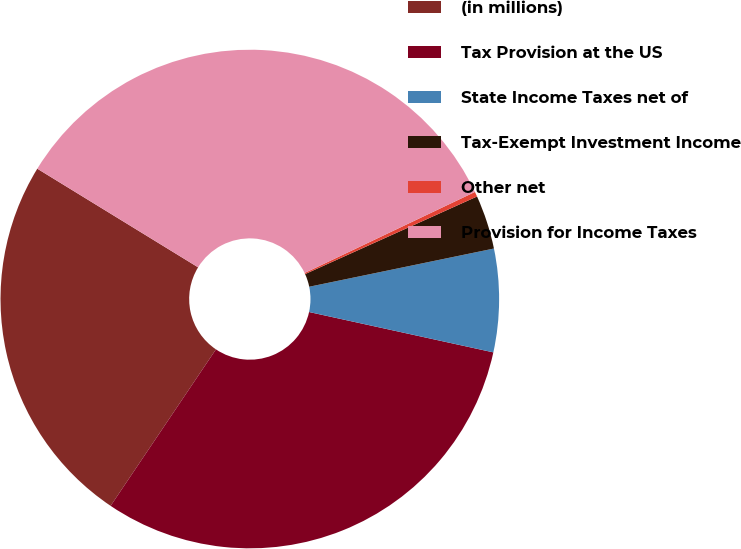<chart> <loc_0><loc_0><loc_500><loc_500><pie_chart><fcel>(in millions)<fcel>Tax Provision at the US<fcel>State Income Taxes net of<fcel>Tax-Exempt Investment Income<fcel>Other net<fcel>Provision for Income Taxes<nl><fcel>24.33%<fcel>31.0%<fcel>6.68%<fcel>3.5%<fcel>0.32%<fcel>34.18%<nl></chart> 